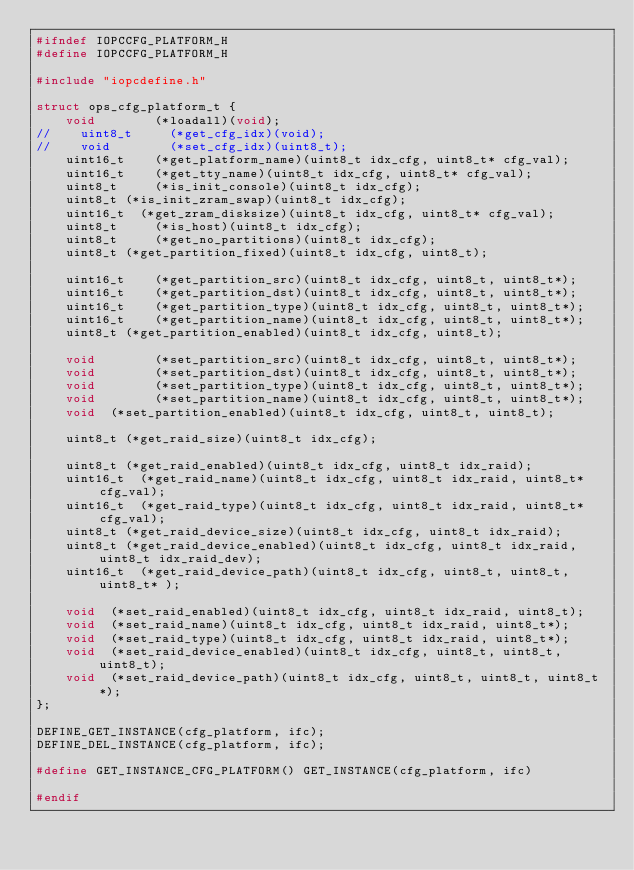Convert code to text. <code><loc_0><loc_0><loc_500><loc_500><_C_>#ifndef IOPCCFG_PLATFORM_H
#define IOPCCFG_PLATFORM_H

#include "iopcdefine.h"

struct ops_cfg_platform_t {
    void        (*loadall)(void);
//    uint8_t     (*get_cfg_idx)(void);
//    void        (*set_cfg_idx)(uint8_t);
    uint16_t    (*get_platform_name)(uint8_t idx_cfg, uint8_t* cfg_val);
    uint16_t    (*get_tty_name)(uint8_t idx_cfg, uint8_t* cfg_val);
    uint8_t     (*is_init_console)(uint8_t idx_cfg);
    uint8_t	(*is_init_zram_swap)(uint8_t idx_cfg);
    uint16_t	(*get_zram_disksize)(uint8_t idx_cfg, uint8_t* cfg_val);
    uint8_t     (*is_host)(uint8_t idx_cfg);
    uint8_t     (*get_no_partitions)(uint8_t idx_cfg);
    uint8_t	(*get_partition_fixed)(uint8_t idx_cfg, uint8_t);

    uint16_t    (*get_partition_src)(uint8_t idx_cfg, uint8_t, uint8_t*);
    uint16_t    (*get_partition_dst)(uint8_t idx_cfg, uint8_t, uint8_t*);
    uint16_t    (*get_partition_type)(uint8_t idx_cfg, uint8_t, uint8_t*);
    uint16_t    (*get_partition_name)(uint8_t idx_cfg, uint8_t, uint8_t*);
    uint8_t	(*get_partition_enabled)(uint8_t idx_cfg, uint8_t);

    void        (*set_partition_src)(uint8_t idx_cfg, uint8_t, uint8_t*);
    void        (*set_partition_dst)(uint8_t idx_cfg, uint8_t, uint8_t*);
    void        (*set_partition_type)(uint8_t idx_cfg, uint8_t, uint8_t*);
    void        (*set_partition_name)(uint8_t idx_cfg, uint8_t, uint8_t*);
    void	(*set_partition_enabled)(uint8_t idx_cfg, uint8_t, uint8_t);

    uint8_t	(*get_raid_size)(uint8_t idx_cfg);

    uint8_t	(*get_raid_enabled)(uint8_t idx_cfg, uint8_t idx_raid);
    uint16_t	(*get_raid_name)(uint8_t idx_cfg, uint8_t idx_raid, uint8_t* cfg_val);
    uint16_t	(*get_raid_type)(uint8_t idx_cfg, uint8_t idx_raid, uint8_t* cfg_val);
    uint8_t	(*get_raid_device_size)(uint8_t idx_cfg, uint8_t idx_raid);
    uint8_t	(*get_raid_device_enabled)(uint8_t idx_cfg, uint8_t idx_raid, uint8_t idx_raid_dev);
    uint16_t	(*get_raid_device_path)(uint8_t idx_cfg, uint8_t, uint8_t, uint8_t* );

    void	(*set_raid_enabled)(uint8_t idx_cfg, uint8_t idx_raid, uint8_t);
    void	(*set_raid_name)(uint8_t idx_cfg, uint8_t idx_raid, uint8_t*);
    void	(*set_raid_type)(uint8_t idx_cfg, uint8_t idx_raid, uint8_t*);
    void	(*set_raid_device_enabled)(uint8_t idx_cfg, uint8_t, uint8_t, uint8_t);
    void	(*set_raid_device_path)(uint8_t idx_cfg, uint8_t, uint8_t, uint8_t*);
};

DEFINE_GET_INSTANCE(cfg_platform, ifc);
DEFINE_DEL_INSTANCE(cfg_platform, ifc);

#define GET_INSTANCE_CFG_PLATFORM() GET_INSTANCE(cfg_platform, ifc)

#endif
</code> 